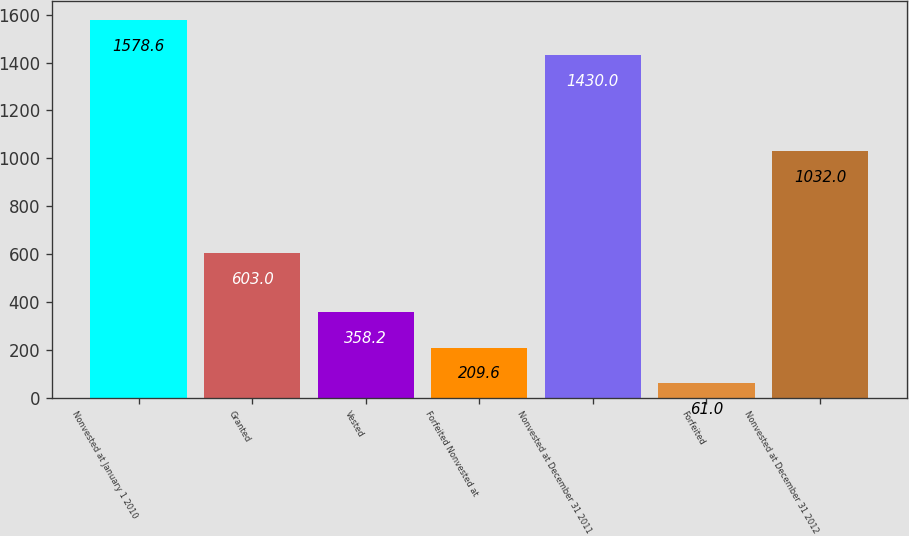Convert chart. <chart><loc_0><loc_0><loc_500><loc_500><bar_chart><fcel>Nonvested at January 1 2010<fcel>Granted<fcel>Vested<fcel>Forfeited Nonvested at<fcel>Nonvested at December 31 2011<fcel>Forfeited<fcel>Nonvested at December 31 2012<nl><fcel>1578.6<fcel>603<fcel>358.2<fcel>209.6<fcel>1430<fcel>61<fcel>1032<nl></chart> 